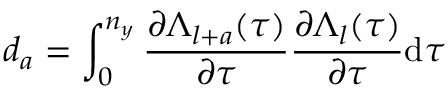Convert formula to latex. <formula><loc_0><loc_0><loc_500><loc_500>d _ { a } = \int _ { 0 } ^ { n _ { y } } \frac { \partial \Lambda _ { l + a } ( \tau ) } { \partial \tau } \frac { \partial \Lambda _ { l } ( \tau ) } { \partial \tau } d \tau</formula> 